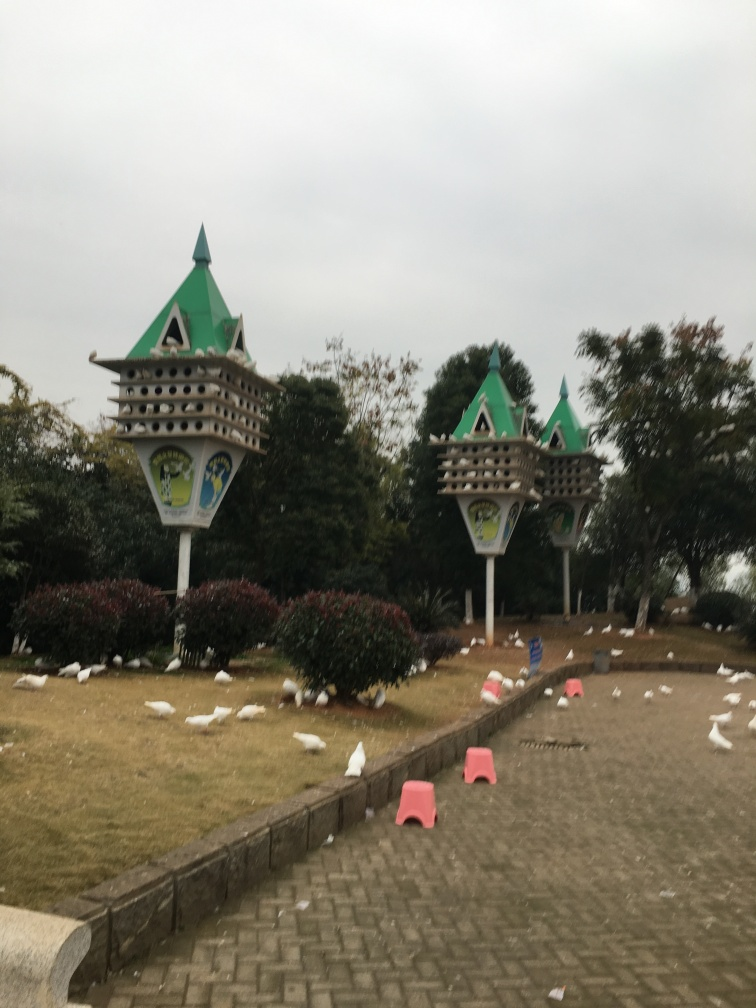Is the overall quality of the image poor? The image quality appears to exhibit some deficiencies, such as lack of sharpness and potential overcast lighting conditions, which could detract from the clarity and detail perceived by viewers. 